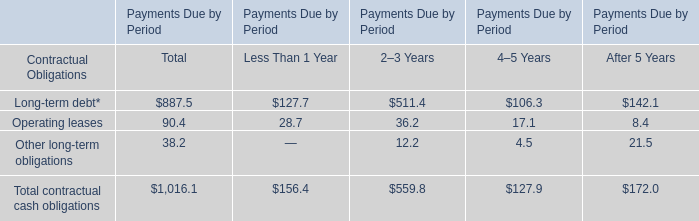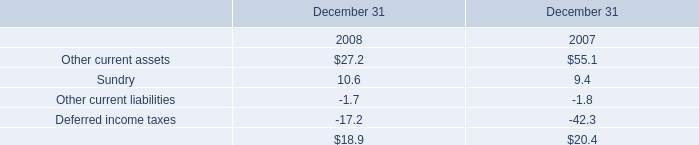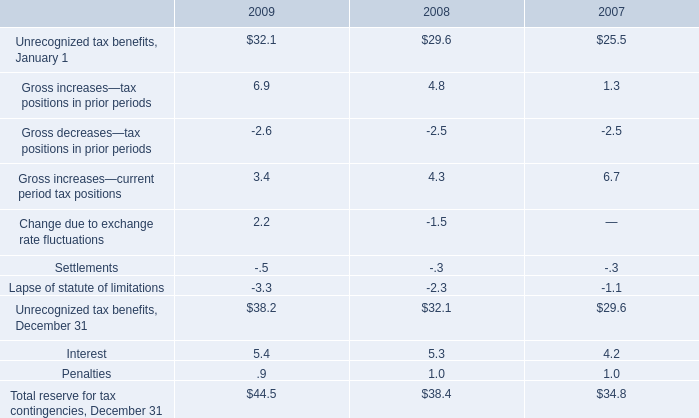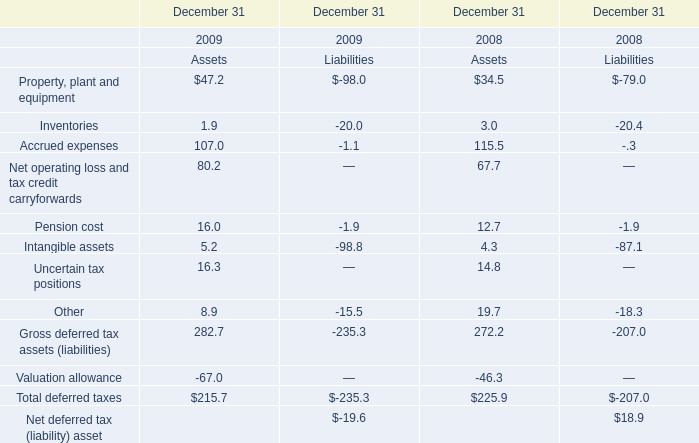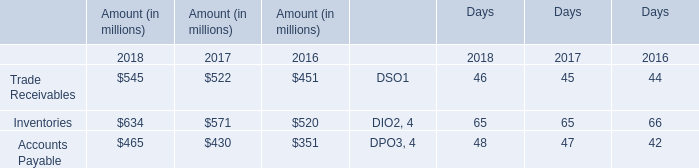In which year is Gross increases—current period tax positions positive? 
Answer: 2007 2008 2009. 